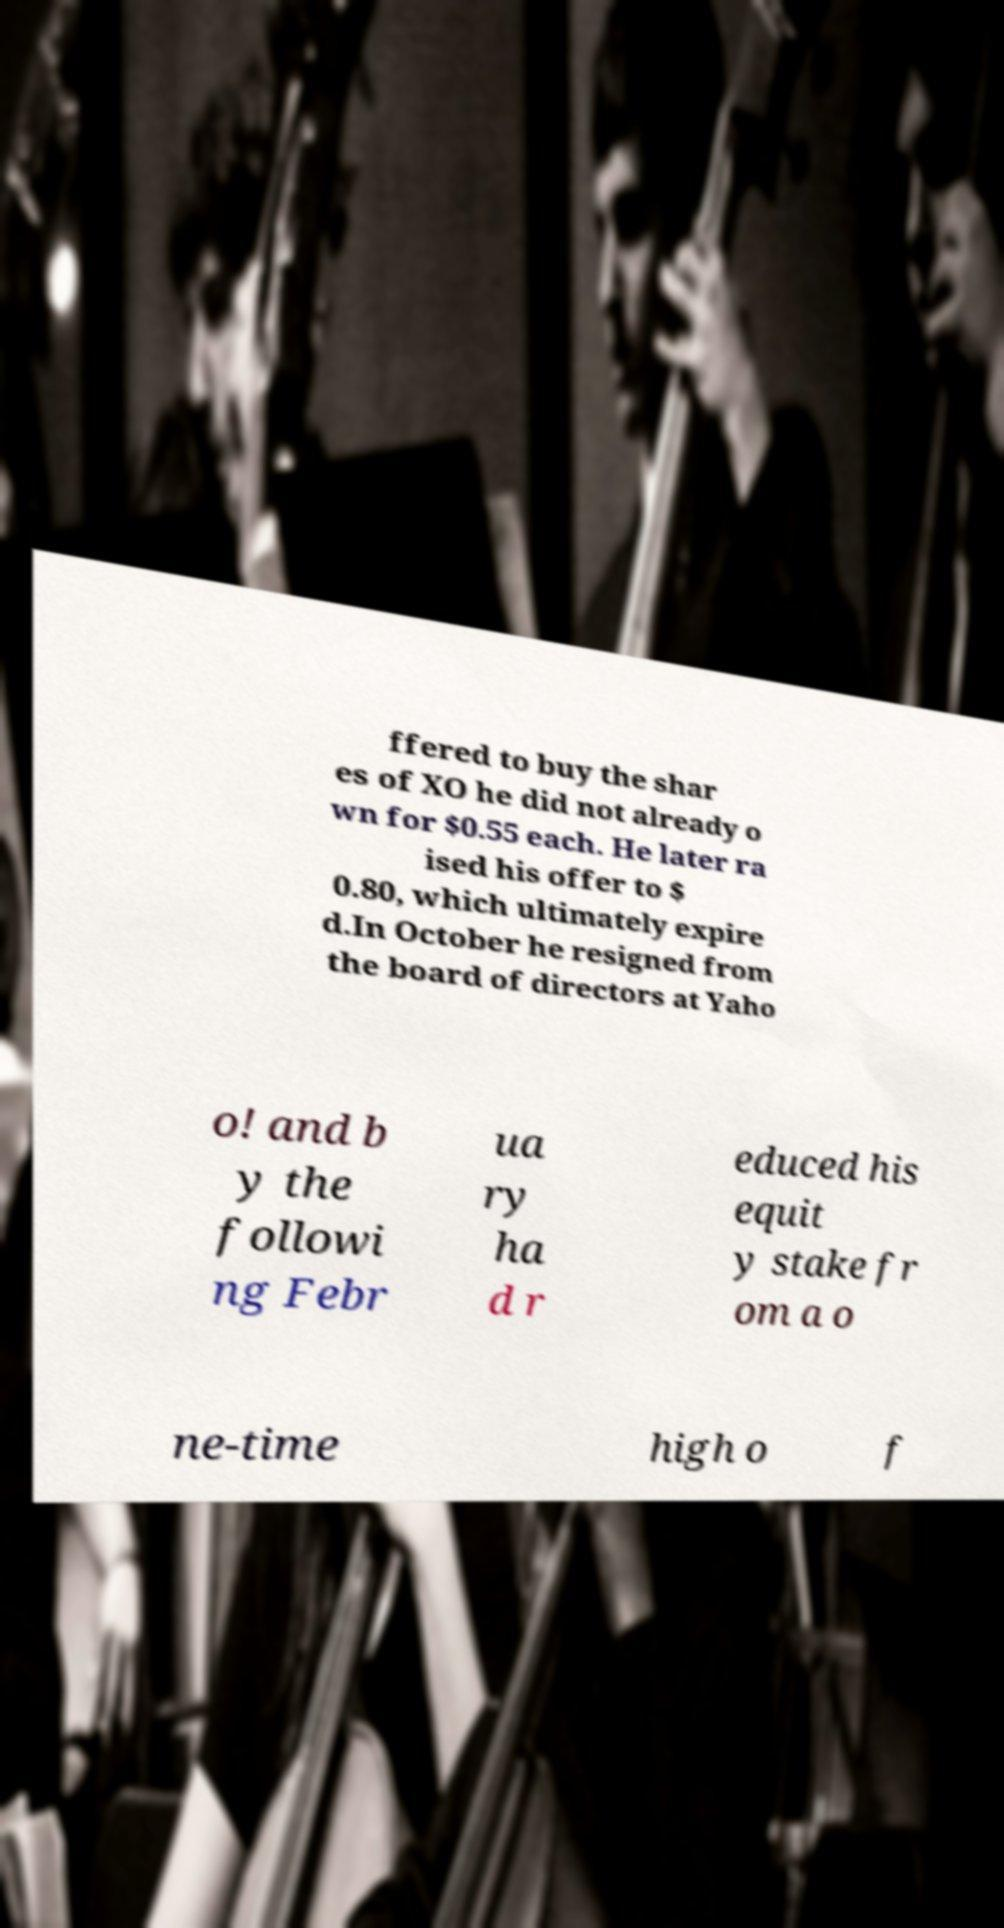Can you accurately transcribe the text from the provided image for me? ffered to buy the shar es of XO he did not already o wn for $0.55 each. He later ra ised his offer to $ 0.80, which ultimately expire d.In October he resigned from the board of directors at Yaho o! and b y the followi ng Febr ua ry ha d r educed his equit y stake fr om a o ne-time high o f 